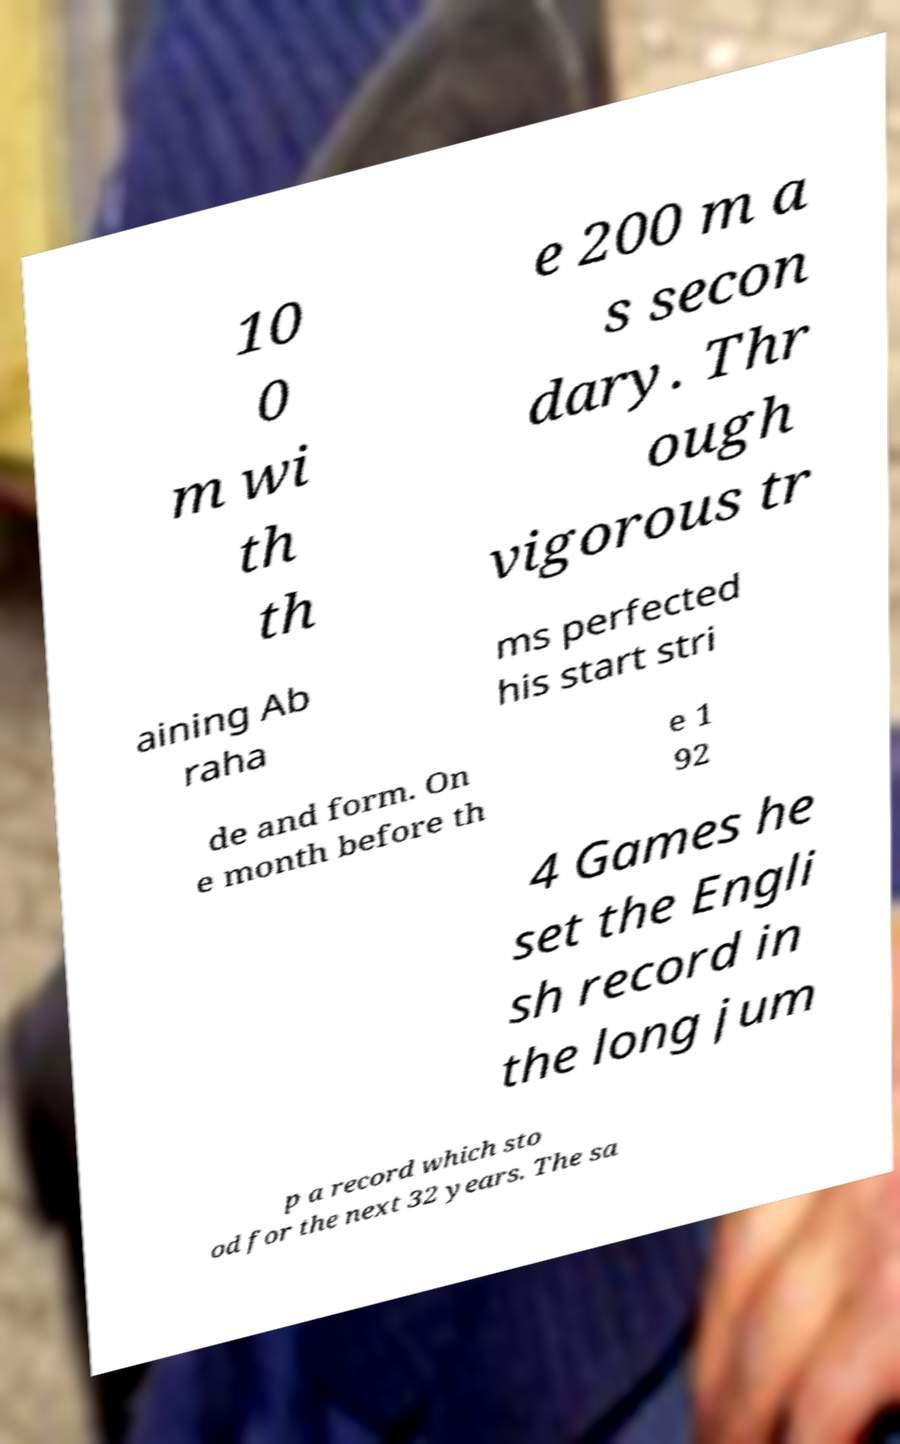Could you assist in decoding the text presented in this image and type it out clearly? 10 0 m wi th th e 200 m a s secon dary. Thr ough vigorous tr aining Ab raha ms perfected his start stri de and form. On e month before th e 1 92 4 Games he set the Engli sh record in the long jum p a record which sto od for the next 32 years. The sa 